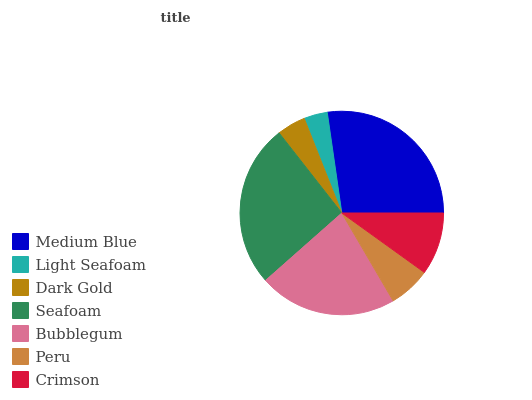Is Light Seafoam the minimum?
Answer yes or no. Yes. Is Medium Blue the maximum?
Answer yes or no. Yes. Is Dark Gold the minimum?
Answer yes or no. No. Is Dark Gold the maximum?
Answer yes or no. No. Is Dark Gold greater than Light Seafoam?
Answer yes or no. Yes. Is Light Seafoam less than Dark Gold?
Answer yes or no. Yes. Is Light Seafoam greater than Dark Gold?
Answer yes or no. No. Is Dark Gold less than Light Seafoam?
Answer yes or no. No. Is Crimson the high median?
Answer yes or no. Yes. Is Crimson the low median?
Answer yes or no. Yes. Is Dark Gold the high median?
Answer yes or no. No. Is Peru the low median?
Answer yes or no. No. 